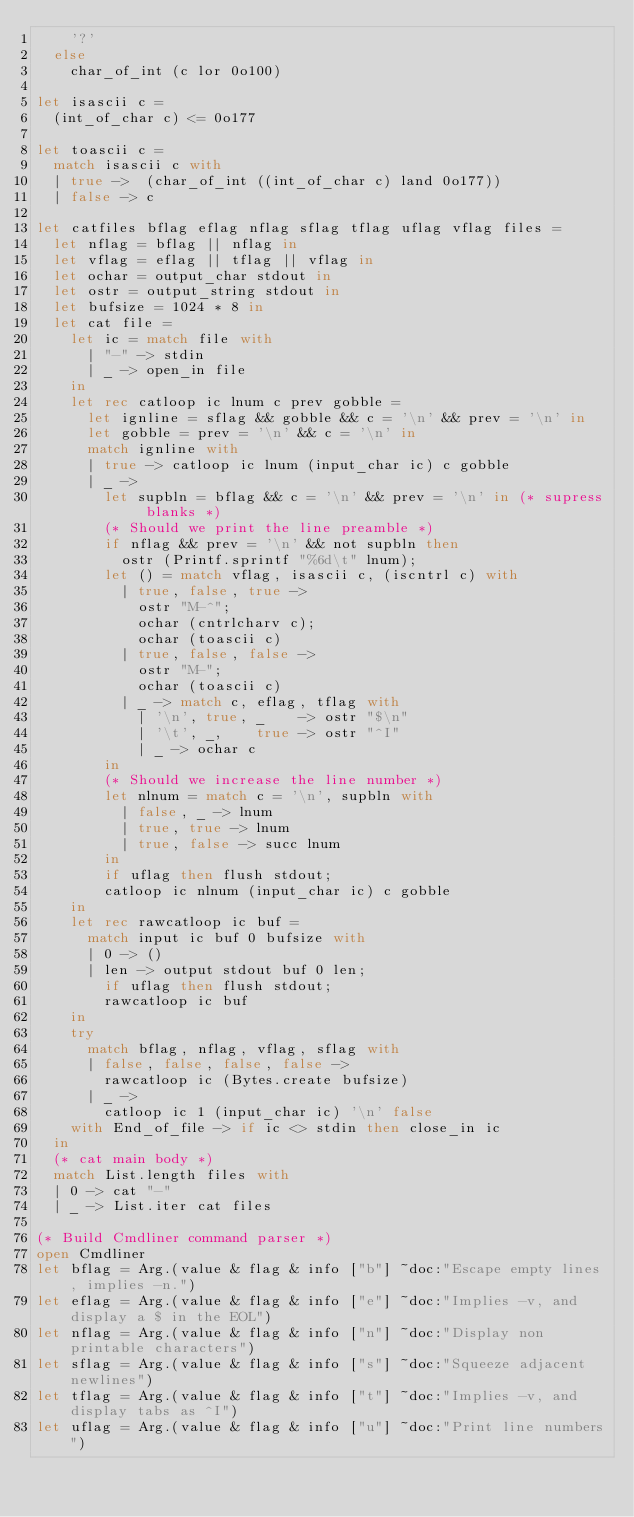Convert code to text. <code><loc_0><loc_0><loc_500><loc_500><_OCaml_>    '?'
  else
    char_of_int (c lor 0o100)

let isascii c =
  (int_of_char c) <= 0o177

let toascii c =
  match isascii c with
  | true ->  (char_of_int ((int_of_char c) land 0o177))
  | false -> c

let catfiles bflag eflag nflag sflag tflag uflag vflag files =
  let nflag = bflag || nflag in
  let vflag = eflag || tflag || vflag in
  let ochar = output_char stdout in
  let ostr = output_string stdout in
  let bufsize = 1024 * 8 in
  let cat file =
    let ic = match file with
      | "-" -> stdin
      | _ -> open_in file
    in
    let rec catloop ic lnum c prev gobble =
      let ignline = sflag && gobble && c = '\n' && prev = '\n' in
      let gobble = prev = '\n' && c = '\n' in
      match ignline with
      | true -> catloop ic lnum (input_char ic) c gobble
      | _ ->
        let supbln = bflag && c = '\n' && prev = '\n' in (* supress blanks *)
        (* Should we print the line preamble *)
        if nflag && prev = '\n' && not supbln then
          ostr (Printf.sprintf "%6d\t" lnum);
        let () = match vflag, isascii c, (iscntrl c) with
          | true, false, true ->
            ostr "M-^";
            ochar (cntrlcharv c);
            ochar (toascii c)
          | true, false, false ->
            ostr "M-";
            ochar (toascii c)
          | _ -> match c, eflag, tflag with
            | '\n', true, _    -> ostr "$\n"
            | '\t', _,    true -> ostr "^I"
            | _ -> ochar c
        in
        (* Should we increase the line number *)
        let nlnum = match c = '\n', supbln with
          | false, _ -> lnum
          | true, true -> lnum
          | true, false -> succ lnum
        in
        if uflag then flush stdout;
        catloop ic nlnum (input_char ic) c gobble
    in
    let rec rawcatloop ic buf =
      match input ic buf 0 bufsize with
      | 0 -> ()
      | len -> output stdout buf 0 len;
        if uflag then flush stdout;
        rawcatloop ic buf
    in
    try
      match bflag, nflag, vflag, sflag with
      | false, false, false, false ->
        rawcatloop ic (Bytes.create bufsize)
      | _ ->
        catloop ic 1 (input_char ic) '\n' false
    with End_of_file -> if ic <> stdin then close_in ic
  in
  (* cat main body *)
  match List.length files with
  | 0 -> cat "-"
  | _ -> List.iter cat files

(* Build Cmdliner command parser *)
open Cmdliner
let bflag = Arg.(value & flag & info ["b"] ~doc:"Escape empty lines, implies -n.")
let eflag = Arg.(value & flag & info ["e"] ~doc:"Implies -v, and display a $ in the EOL")
let nflag = Arg.(value & flag & info ["n"] ~doc:"Display non printable characters")
let sflag = Arg.(value & flag & info ["s"] ~doc:"Squeeze adjacent newlines")
let tflag = Arg.(value & flag & info ["t"] ~doc:"Implies -v, and display tabs as ^I")
let uflag = Arg.(value & flag & info ["u"] ~doc:"Print line numbers")</code> 